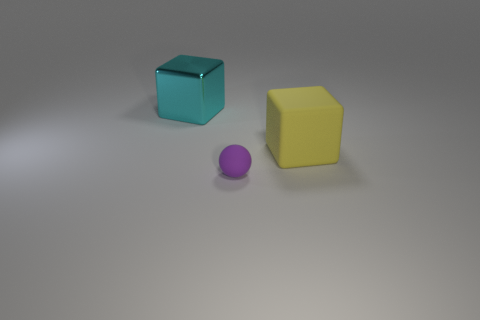What materials do these objects seem to be made of? Based on the visual appearance, the large yellow cube and the small purple sphere seem to have a plastic-like material due to their smooth and uniform surfaces. The blue cube, on the other hand, appears slightly transparent and could be made of glass or a translucent plastic. 